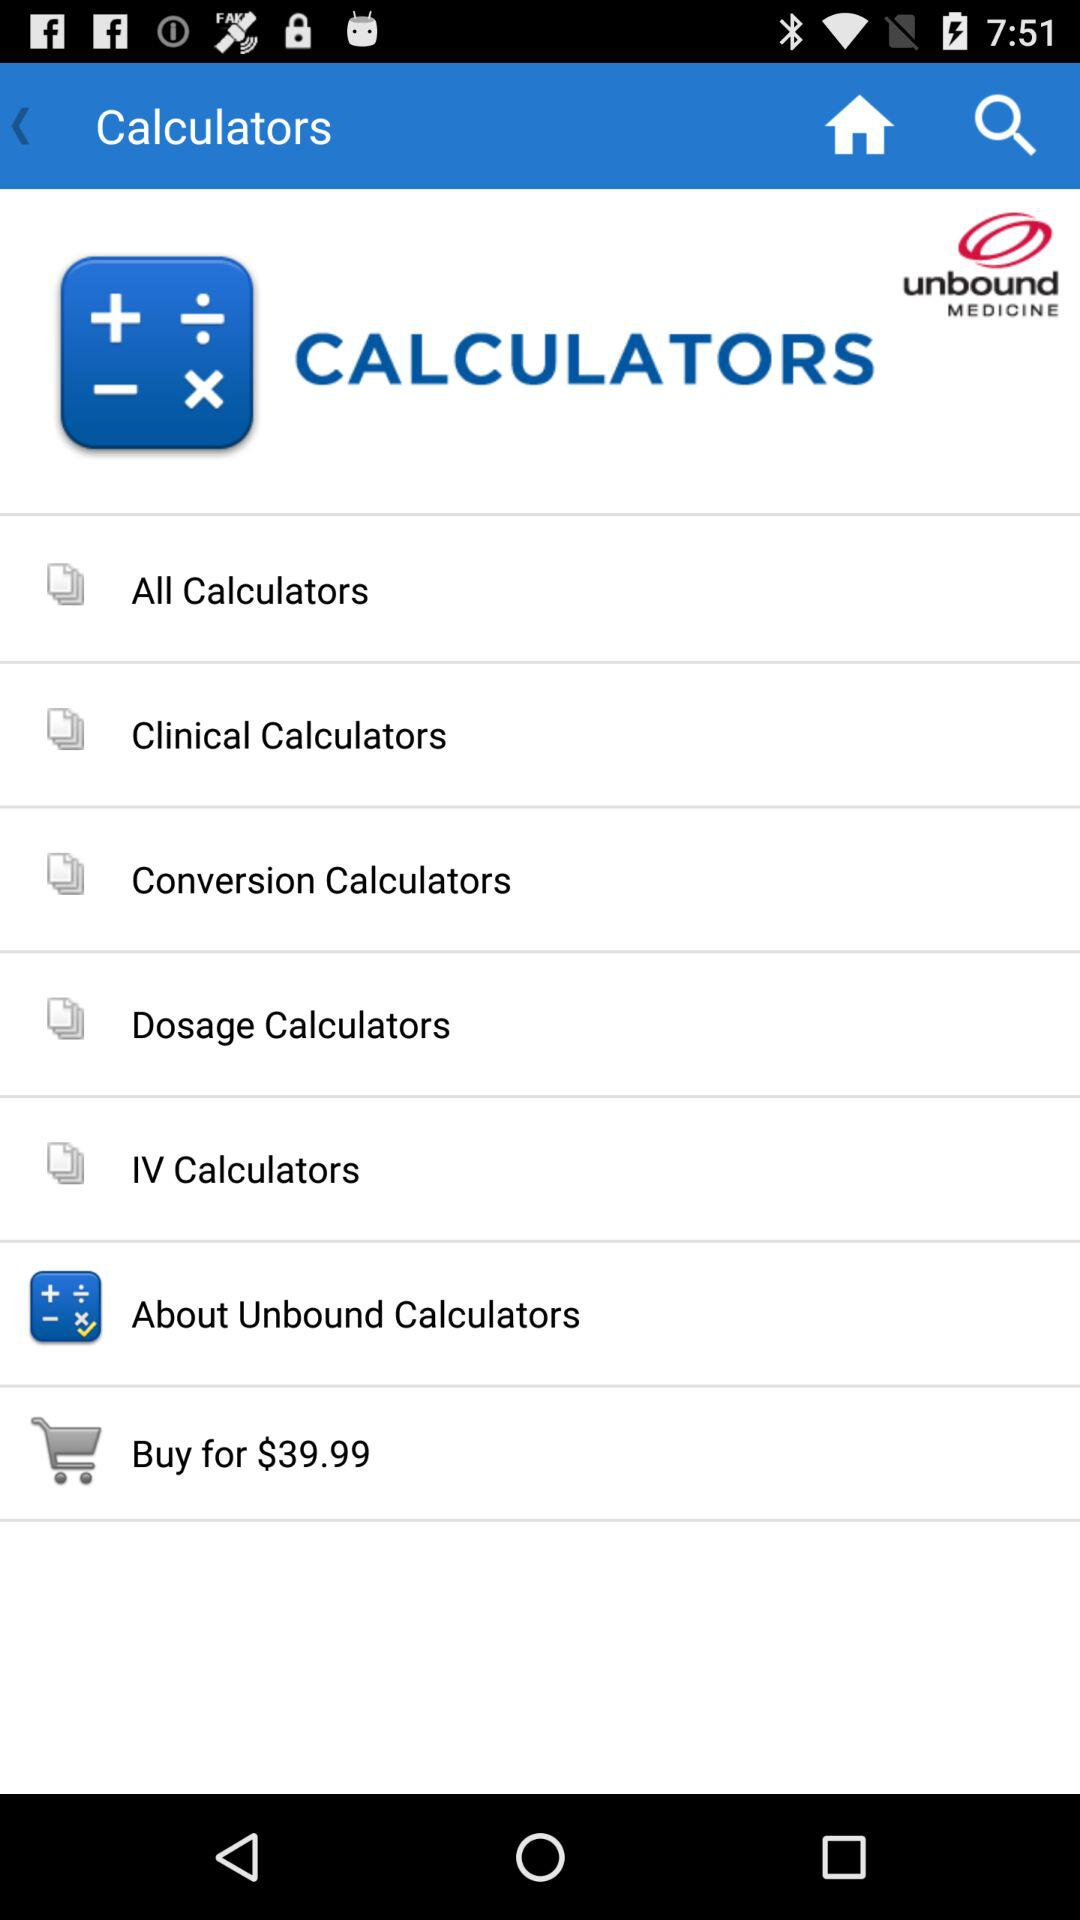What is the currency of the price? The currency is dollars. 